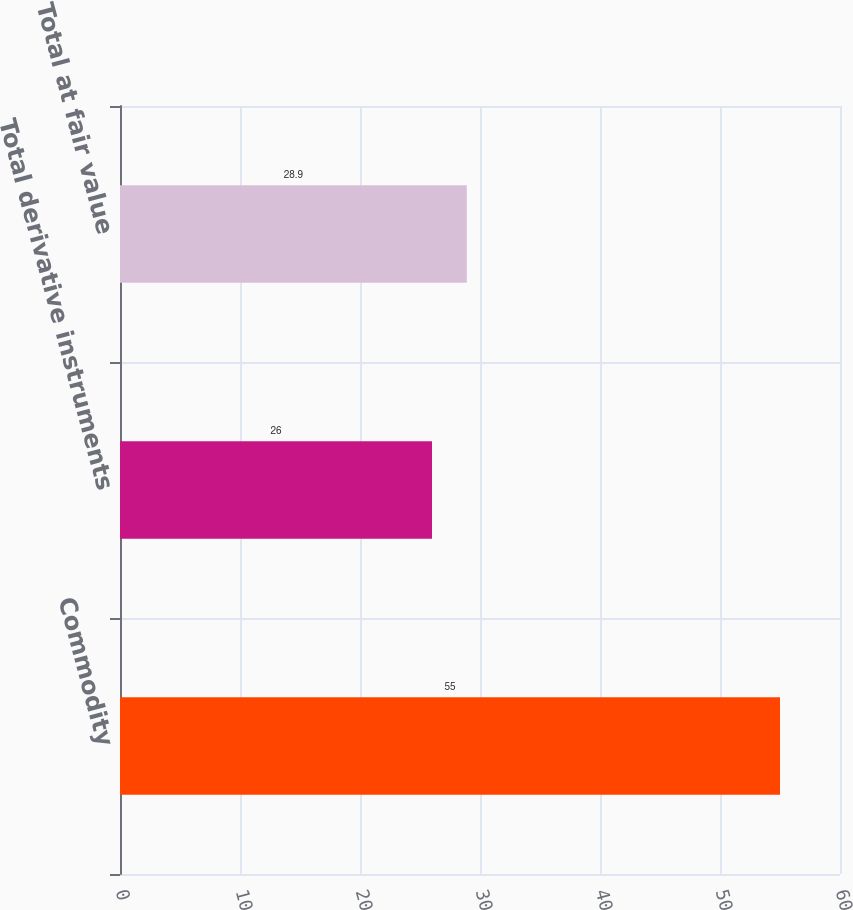Convert chart. <chart><loc_0><loc_0><loc_500><loc_500><bar_chart><fcel>Commodity<fcel>Total derivative instruments<fcel>Total at fair value<nl><fcel>55<fcel>26<fcel>28.9<nl></chart> 